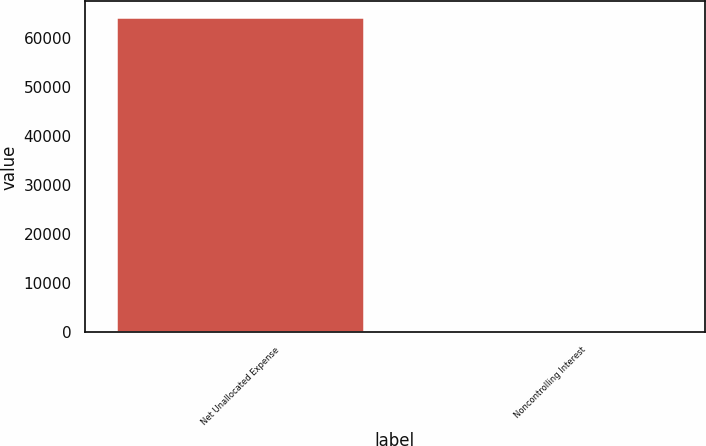Convert chart. <chart><loc_0><loc_0><loc_500><loc_500><bar_chart><fcel>Net Unallocated Expense<fcel>Noncontrolling Interest<nl><fcel>64171<fcel>442<nl></chart> 